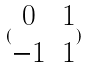Convert formula to latex. <formula><loc_0><loc_0><loc_500><loc_500>( \begin{matrix} 0 & 1 \\ - 1 & 1 \end{matrix} )</formula> 